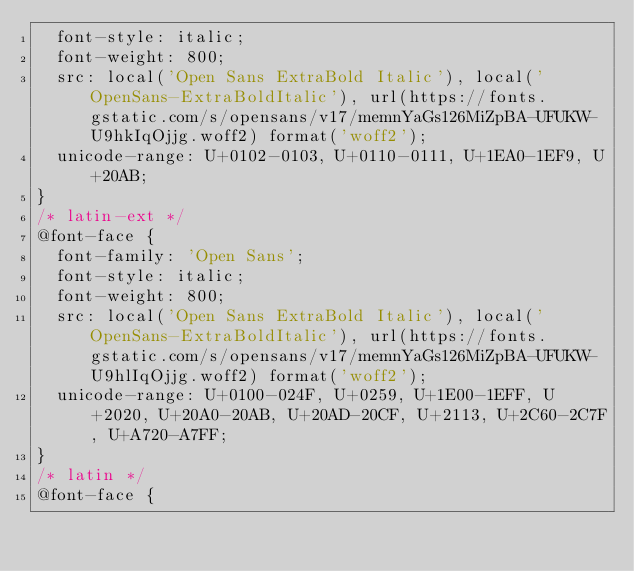Convert code to text. <code><loc_0><loc_0><loc_500><loc_500><_CSS_>  font-style: italic;
  font-weight: 800;
  src: local('Open Sans ExtraBold Italic'), local('OpenSans-ExtraBoldItalic'), url(https://fonts.gstatic.com/s/opensans/v17/memnYaGs126MiZpBA-UFUKW-U9hkIqOjjg.woff2) format('woff2');
  unicode-range: U+0102-0103, U+0110-0111, U+1EA0-1EF9, U+20AB;
}
/* latin-ext */
@font-face {
  font-family: 'Open Sans';
  font-style: italic;
  font-weight: 800;
  src: local('Open Sans ExtraBold Italic'), local('OpenSans-ExtraBoldItalic'), url(https://fonts.gstatic.com/s/opensans/v17/memnYaGs126MiZpBA-UFUKW-U9hlIqOjjg.woff2) format('woff2');
  unicode-range: U+0100-024F, U+0259, U+1E00-1EFF, U+2020, U+20A0-20AB, U+20AD-20CF, U+2113, U+2C60-2C7F, U+A720-A7FF;
}
/* latin */
@font-face {</code> 